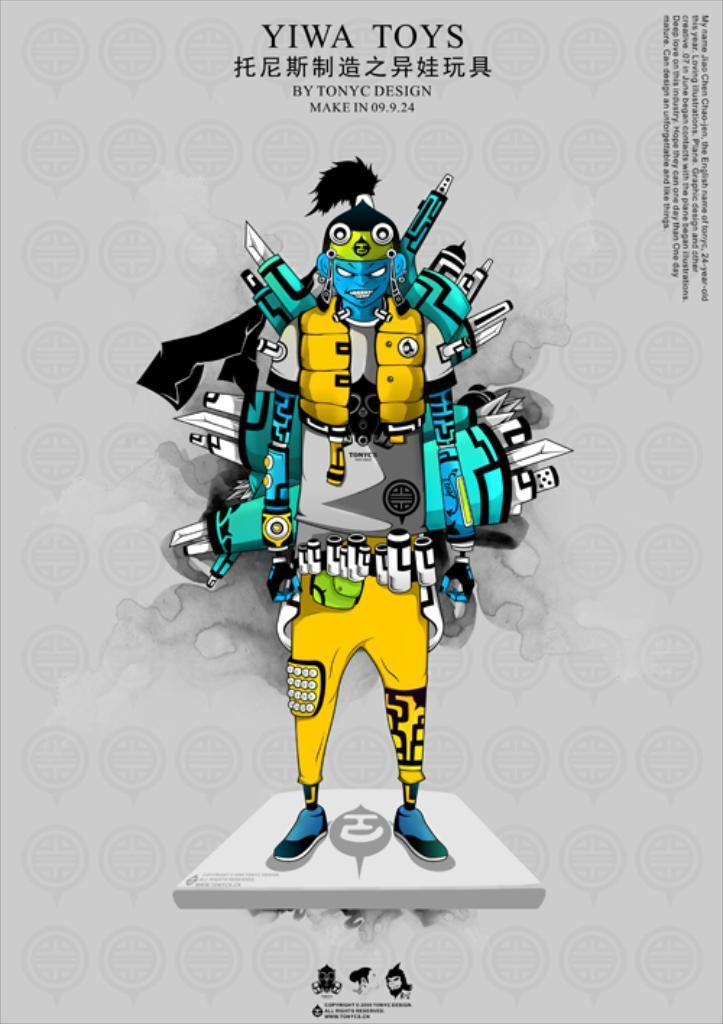In one or two sentences, can you explain what this image depicts? It is an animated pic in the shape of a human. It is in yellow color. 